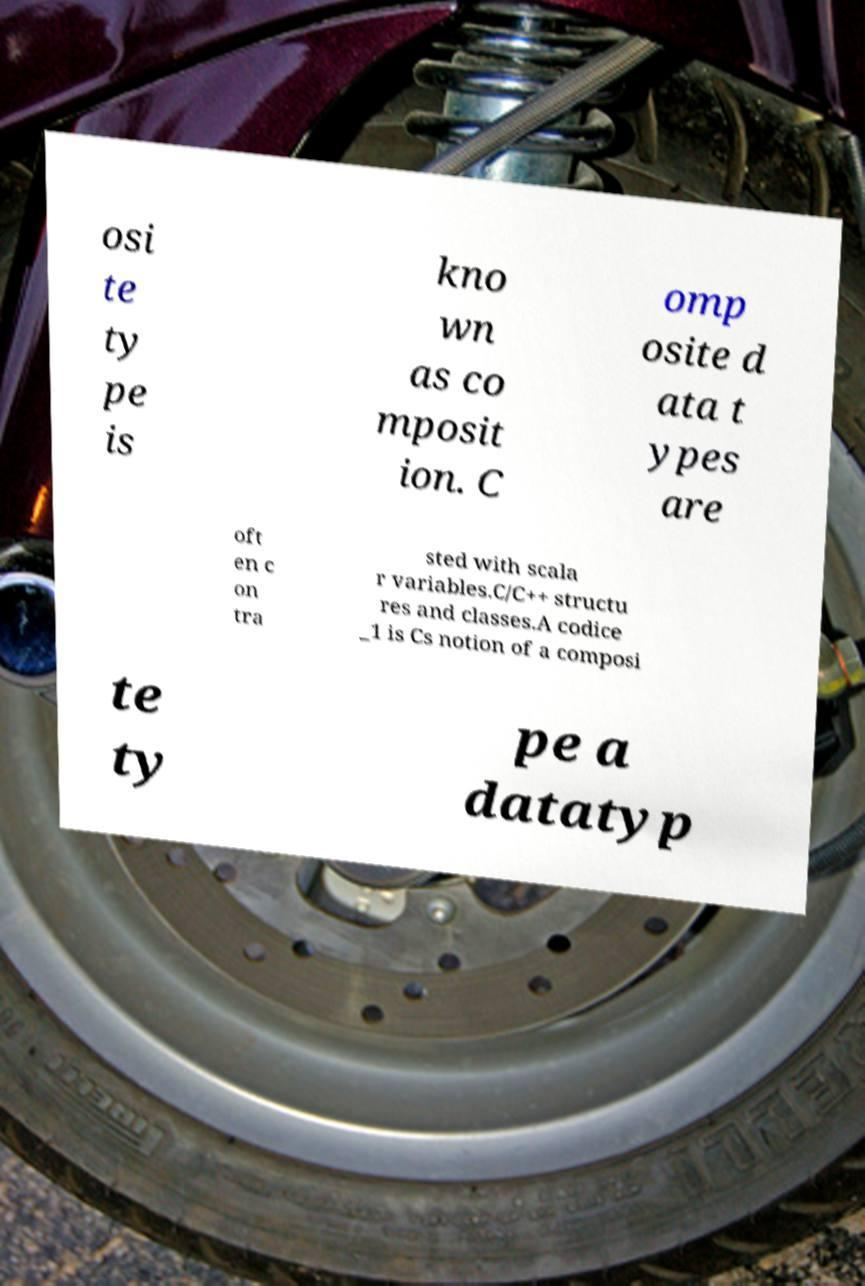Could you assist in decoding the text presented in this image and type it out clearly? osi te ty pe is kno wn as co mposit ion. C omp osite d ata t ypes are oft en c on tra sted with scala r variables.C/C++ structu res and classes.A codice _1 is Cs notion of a composi te ty pe a datatyp 